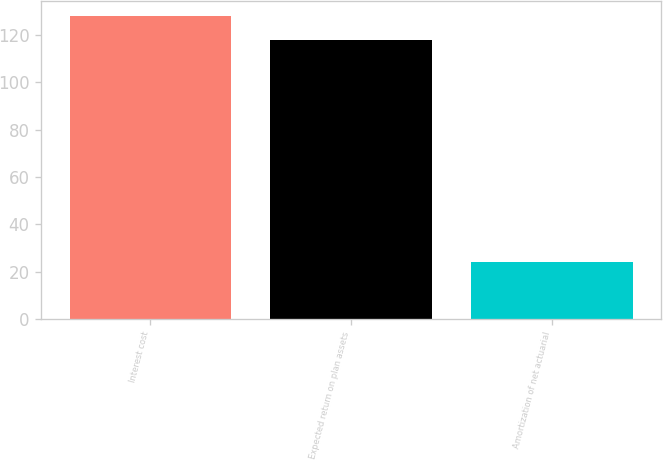<chart> <loc_0><loc_0><loc_500><loc_500><bar_chart><fcel>Interest cost<fcel>Expected return on plan assets<fcel>Amortization of net actuarial<nl><fcel>128<fcel>118<fcel>24<nl></chart> 